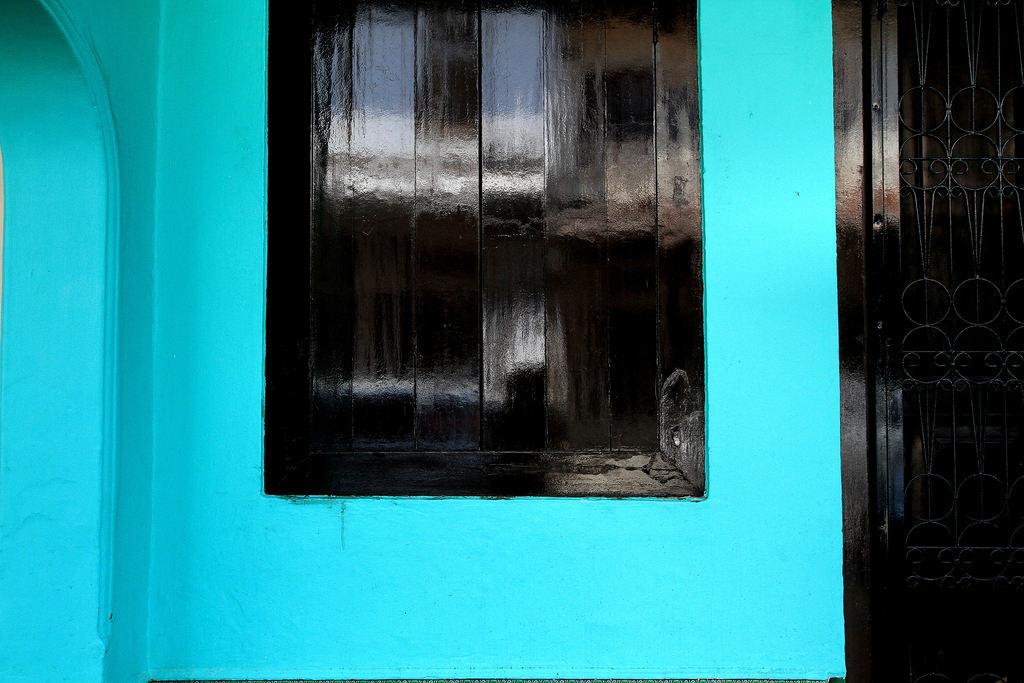What is the color of the wall in the image? The wall in the image is blue. What architectural feature can be seen in the image? There is a window and a door in the image. When was the image taken, based on the lighting? The image was taken during the day, as there is sufficient natural light. What type of cap can be seen hanging on the door in the image? There is no cap visible in the image; it only features a blue wall, a window, and a door. 